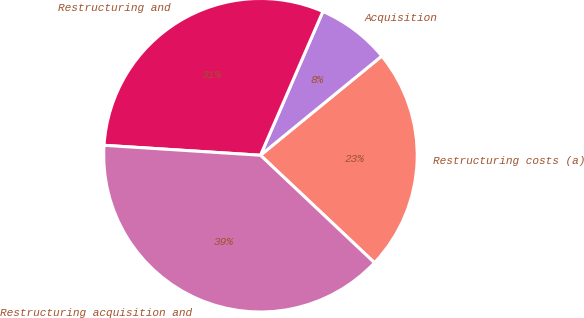Convert chart to OTSL. <chart><loc_0><loc_0><loc_500><loc_500><pie_chart><fcel>Restructuring costs (a)<fcel>Acquisition<fcel>Restructuring and<fcel>Restructuring acquisition and<nl><fcel>22.94%<fcel>7.57%<fcel>30.51%<fcel>38.98%<nl></chart> 